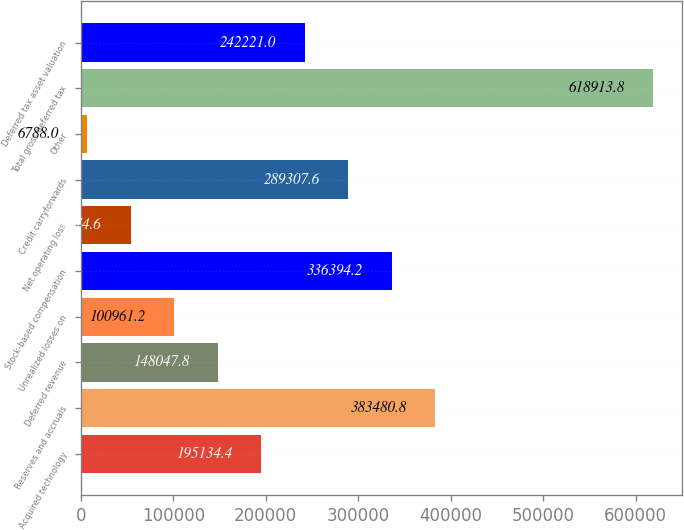Convert chart. <chart><loc_0><loc_0><loc_500><loc_500><bar_chart><fcel>Acquired technology<fcel>Reserves and accruals<fcel>Deferred revenue<fcel>Unrealized losses on<fcel>Stock-based compensation<fcel>Net operating loss<fcel>Credit carryforwards<fcel>Other<fcel>Total gross deferred tax<fcel>Deferred tax asset valuation<nl><fcel>195134<fcel>383481<fcel>148048<fcel>100961<fcel>336394<fcel>53874.6<fcel>289308<fcel>6788<fcel>618914<fcel>242221<nl></chart> 